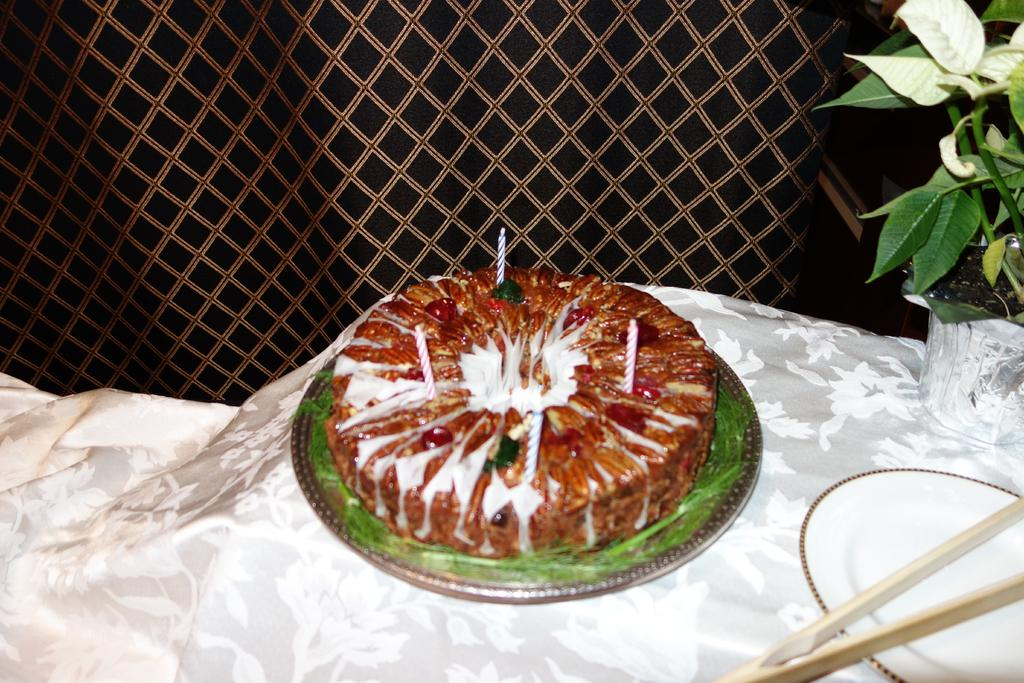What is the main food item in the image? There is a cake in the image. What is the cake placed on? There is a plate in the image. What other object can be seen in the image? There is a flower pot in the image. What type of prose is written on the cake in the image? There is no prose written on the cake in the image. Can you see a sock near the cake in the image? There is no sock present in the image. 